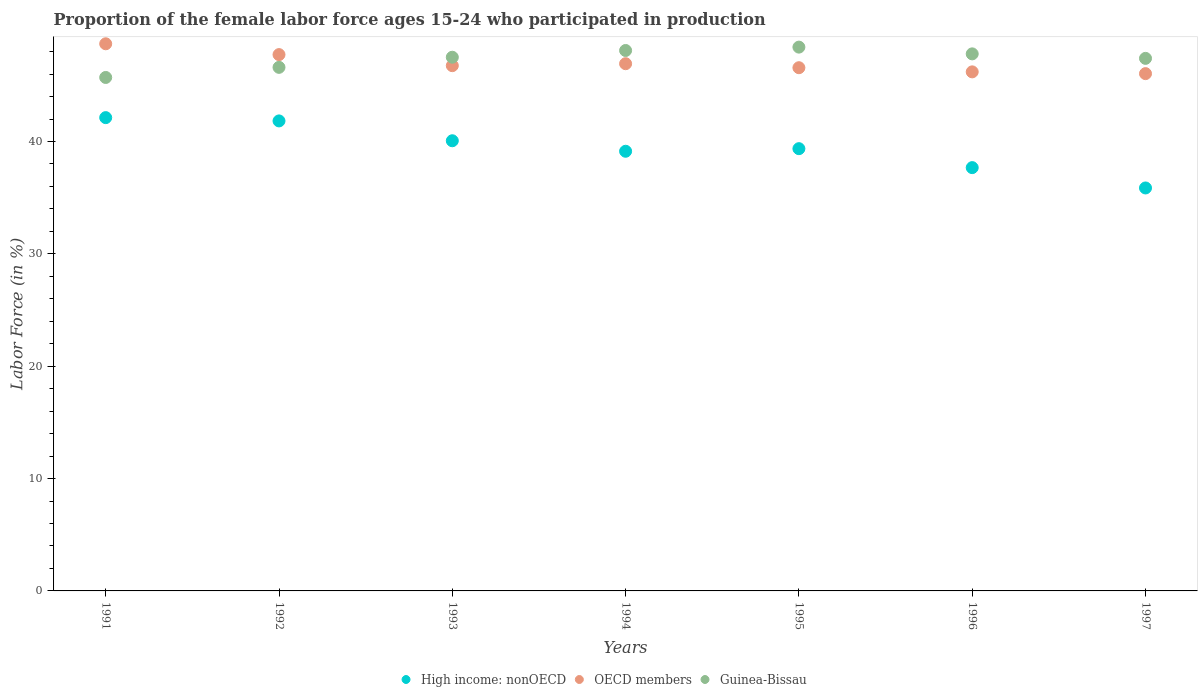How many different coloured dotlines are there?
Offer a terse response. 3. What is the proportion of the female labor force who participated in production in OECD members in 1997?
Your answer should be compact. 46.04. Across all years, what is the maximum proportion of the female labor force who participated in production in OECD members?
Your response must be concise. 48.7. Across all years, what is the minimum proportion of the female labor force who participated in production in OECD members?
Provide a short and direct response. 46.04. What is the total proportion of the female labor force who participated in production in Guinea-Bissau in the graph?
Your answer should be very brief. 331.5. What is the difference between the proportion of the female labor force who participated in production in High income: nonOECD in 1993 and that in 1994?
Your answer should be very brief. 0.93. What is the difference between the proportion of the female labor force who participated in production in OECD members in 1992 and the proportion of the female labor force who participated in production in Guinea-Bissau in 1995?
Keep it short and to the point. -0.67. What is the average proportion of the female labor force who participated in production in Guinea-Bissau per year?
Provide a short and direct response. 47.36. In the year 1997, what is the difference between the proportion of the female labor force who participated in production in OECD members and proportion of the female labor force who participated in production in Guinea-Bissau?
Make the answer very short. -1.36. In how many years, is the proportion of the female labor force who participated in production in Guinea-Bissau greater than 16 %?
Your answer should be compact. 7. What is the ratio of the proportion of the female labor force who participated in production in Guinea-Bissau in 1991 to that in 1995?
Make the answer very short. 0.94. Is the difference between the proportion of the female labor force who participated in production in OECD members in 1991 and 1994 greater than the difference between the proportion of the female labor force who participated in production in Guinea-Bissau in 1991 and 1994?
Keep it short and to the point. Yes. What is the difference between the highest and the second highest proportion of the female labor force who participated in production in OECD members?
Your response must be concise. 0.96. What is the difference between the highest and the lowest proportion of the female labor force who participated in production in OECD members?
Your response must be concise. 2.66. Is the sum of the proportion of the female labor force who participated in production in High income: nonOECD in 1991 and 1997 greater than the maximum proportion of the female labor force who participated in production in OECD members across all years?
Give a very brief answer. Yes. Is the proportion of the female labor force who participated in production in OECD members strictly less than the proportion of the female labor force who participated in production in Guinea-Bissau over the years?
Give a very brief answer. No. How many years are there in the graph?
Ensure brevity in your answer.  7. What is the difference between two consecutive major ticks on the Y-axis?
Your answer should be compact. 10. Are the values on the major ticks of Y-axis written in scientific E-notation?
Provide a succinct answer. No. Where does the legend appear in the graph?
Provide a succinct answer. Bottom center. How many legend labels are there?
Your response must be concise. 3. How are the legend labels stacked?
Make the answer very short. Horizontal. What is the title of the graph?
Make the answer very short. Proportion of the female labor force ages 15-24 who participated in production. Does "Libya" appear as one of the legend labels in the graph?
Make the answer very short. No. What is the label or title of the X-axis?
Provide a succinct answer. Years. What is the Labor Force (in %) in High income: nonOECD in 1991?
Provide a short and direct response. 42.12. What is the Labor Force (in %) in OECD members in 1991?
Make the answer very short. 48.7. What is the Labor Force (in %) of Guinea-Bissau in 1991?
Your answer should be very brief. 45.7. What is the Labor Force (in %) in High income: nonOECD in 1992?
Your answer should be compact. 41.83. What is the Labor Force (in %) in OECD members in 1992?
Provide a succinct answer. 47.73. What is the Labor Force (in %) of Guinea-Bissau in 1992?
Make the answer very short. 46.6. What is the Labor Force (in %) of High income: nonOECD in 1993?
Keep it short and to the point. 40.07. What is the Labor Force (in %) of OECD members in 1993?
Keep it short and to the point. 46.75. What is the Labor Force (in %) of Guinea-Bissau in 1993?
Your answer should be very brief. 47.5. What is the Labor Force (in %) in High income: nonOECD in 1994?
Offer a very short reply. 39.13. What is the Labor Force (in %) of OECD members in 1994?
Make the answer very short. 46.92. What is the Labor Force (in %) in Guinea-Bissau in 1994?
Give a very brief answer. 48.1. What is the Labor Force (in %) in High income: nonOECD in 1995?
Make the answer very short. 39.36. What is the Labor Force (in %) in OECD members in 1995?
Keep it short and to the point. 46.57. What is the Labor Force (in %) in Guinea-Bissau in 1995?
Offer a terse response. 48.4. What is the Labor Force (in %) of High income: nonOECD in 1996?
Offer a very short reply. 37.68. What is the Labor Force (in %) of OECD members in 1996?
Provide a short and direct response. 46.2. What is the Labor Force (in %) of Guinea-Bissau in 1996?
Your response must be concise. 47.8. What is the Labor Force (in %) of High income: nonOECD in 1997?
Your response must be concise. 35.87. What is the Labor Force (in %) of OECD members in 1997?
Give a very brief answer. 46.04. What is the Labor Force (in %) of Guinea-Bissau in 1997?
Give a very brief answer. 47.4. Across all years, what is the maximum Labor Force (in %) in High income: nonOECD?
Make the answer very short. 42.12. Across all years, what is the maximum Labor Force (in %) of OECD members?
Provide a short and direct response. 48.7. Across all years, what is the maximum Labor Force (in %) of Guinea-Bissau?
Your response must be concise. 48.4. Across all years, what is the minimum Labor Force (in %) of High income: nonOECD?
Provide a succinct answer. 35.87. Across all years, what is the minimum Labor Force (in %) in OECD members?
Your response must be concise. 46.04. Across all years, what is the minimum Labor Force (in %) of Guinea-Bissau?
Ensure brevity in your answer.  45.7. What is the total Labor Force (in %) in High income: nonOECD in the graph?
Make the answer very short. 276.06. What is the total Labor Force (in %) in OECD members in the graph?
Keep it short and to the point. 328.91. What is the total Labor Force (in %) of Guinea-Bissau in the graph?
Your response must be concise. 331.5. What is the difference between the Labor Force (in %) in High income: nonOECD in 1991 and that in 1992?
Make the answer very short. 0.29. What is the difference between the Labor Force (in %) of OECD members in 1991 and that in 1992?
Ensure brevity in your answer.  0.96. What is the difference between the Labor Force (in %) in Guinea-Bissau in 1991 and that in 1992?
Your answer should be compact. -0.9. What is the difference between the Labor Force (in %) of High income: nonOECD in 1991 and that in 1993?
Offer a very short reply. 2.06. What is the difference between the Labor Force (in %) in OECD members in 1991 and that in 1993?
Offer a terse response. 1.95. What is the difference between the Labor Force (in %) of Guinea-Bissau in 1991 and that in 1993?
Make the answer very short. -1.8. What is the difference between the Labor Force (in %) in High income: nonOECD in 1991 and that in 1994?
Keep it short and to the point. 2.99. What is the difference between the Labor Force (in %) in OECD members in 1991 and that in 1994?
Your answer should be very brief. 1.77. What is the difference between the Labor Force (in %) of Guinea-Bissau in 1991 and that in 1994?
Provide a short and direct response. -2.4. What is the difference between the Labor Force (in %) of High income: nonOECD in 1991 and that in 1995?
Offer a terse response. 2.76. What is the difference between the Labor Force (in %) of OECD members in 1991 and that in 1995?
Make the answer very short. 2.13. What is the difference between the Labor Force (in %) in Guinea-Bissau in 1991 and that in 1995?
Ensure brevity in your answer.  -2.7. What is the difference between the Labor Force (in %) in High income: nonOECD in 1991 and that in 1996?
Offer a very short reply. 4.45. What is the difference between the Labor Force (in %) of OECD members in 1991 and that in 1996?
Keep it short and to the point. 2.5. What is the difference between the Labor Force (in %) in Guinea-Bissau in 1991 and that in 1996?
Your response must be concise. -2.1. What is the difference between the Labor Force (in %) in High income: nonOECD in 1991 and that in 1997?
Provide a succinct answer. 6.26. What is the difference between the Labor Force (in %) in OECD members in 1991 and that in 1997?
Keep it short and to the point. 2.66. What is the difference between the Labor Force (in %) of Guinea-Bissau in 1991 and that in 1997?
Your answer should be compact. -1.7. What is the difference between the Labor Force (in %) in High income: nonOECD in 1992 and that in 1993?
Provide a succinct answer. 1.77. What is the difference between the Labor Force (in %) in OECD members in 1992 and that in 1993?
Offer a very short reply. 0.98. What is the difference between the Labor Force (in %) of Guinea-Bissau in 1992 and that in 1993?
Your answer should be very brief. -0.9. What is the difference between the Labor Force (in %) in High income: nonOECD in 1992 and that in 1994?
Offer a very short reply. 2.7. What is the difference between the Labor Force (in %) in OECD members in 1992 and that in 1994?
Make the answer very short. 0.81. What is the difference between the Labor Force (in %) of High income: nonOECD in 1992 and that in 1995?
Your answer should be very brief. 2.47. What is the difference between the Labor Force (in %) of OECD members in 1992 and that in 1995?
Provide a short and direct response. 1.17. What is the difference between the Labor Force (in %) of High income: nonOECD in 1992 and that in 1996?
Keep it short and to the point. 4.16. What is the difference between the Labor Force (in %) in OECD members in 1992 and that in 1996?
Your answer should be compact. 1.54. What is the difference between the Labor Force (in %) in High income: nonOECD in 1992 and that in 1997?
Offer a terse response. 5.97. What is the difference between the Labor Force (in %) in OECD members in 1992 and that in 1997?
Your answer should be compact. 1.69. What is the difference between the Labor Force (in %) in High income: nonOECD in 1993 and that in 1994?
Provide a succinct answer. 0.93. What is the difference between the Labor Force (in %) in OECD members in 1993 and that in 1994?
Your answer should be very brief. -0.17. What is the difference between the Labor Force (in %) in Guinea-Bissau in 1993 and that in 1994?
Offer a very short reply. -0.6. What is the difference between the Labor Force (in %) of High income: nonOECD in 1993 and that in 1995?
Offer a terse response. 0.7. What is the difference between the Labor Force (in %) in OECD members in 1993 and that in 1995?
Your answer should be very brief. 0.18. What is the difference between the Labor Force (in %) in Guinea-Bissau in 1993 and that in 1995?
Your answer should be very brief. -0.9. What is the difference between the Labor Force (in %) of High income: nonOECD in 1993 and that in 1996?
Provide a short and direct response. 2.39. What is the difference between the Labor Force (in %) of OECD members in 1993 and that in 1996?
Provide a succinct answer. 0.55. What is the difference between the Labor Force (in %) of High income: nonOECD in 1993 and that in 1997?
Offer a terse response. 4.2. What is the difference between the Labor Force (in %) in OECD members in 1993 and that in 1997?
Your answer should be very brief. 0.71. What is the difference between the Labor Force (in %) in High income: nonOECD in 1994 and that in 1995?
Your answer should be compact. -0.23. What is the difference between the Labor Force (in %) of OECD members in 1994 and that in 1995?
Provide a short and direct response. 0.36. What is the difference between the Labor Force (in %) of Guinea-Bissau in 1994 and that in 1995?
Offer a terse response. -0.3. What is the difference between the Labor Force (in %) in High income: nonOECD in 1994 and that in 1996?
Provide a short and direct response. 1.46. What is the difference between the Labor Force (in %) of OECD members in 1994 and that in 1996?
Offer a very short reply. 0.73. What is the difference between the Labor Force (in %) in High income: nonOECD in 1994 and that in 1997?
Ensure brevity in your answer.  3.27. What is the difference between the Labor Force (in %) in OECD members in 1994 and that in 1997?
Keep it short and to the point. 0.88. What is the difference between the Labor Force (in %) of High income: nonOECD in 1995 and that in 1996?
Offer a very short reply. 1.69. What is the difference between the Labor Force (in %) in OECD members in 1995 and that in 1996?
Ensure brevity in your answer.  0.37. What is the difference between the Labor Force (in %) of Guinea-Bissau in 1995 and that in 1996?
Keep it short and to the point. 0.6. What is the difference between the Labor Force (in %) in High income: nonOECD in 1995 and that in 1997?
Offer a very short reply. 3.5. What is the difference between the Labor Force (in %) in OECD members in 1995 and that in 1997?
Your answer should be compact. 0.53. What is the difference between the Labor Force (in %) in Guinea-Bissau in 1995 and that in 1997?
Keep it short and to the point. 1. What is the difference between the Labor Force (in %) in High income: nonOECD in 1996 and that in 1997?
Ensure brevity in your answer.  1.81. What is the difference between the Labor Force (in %) in OECD members in 1996 and that in 1997?
Provide a succinct answer. 0.16. What is the difference between the Labor Force (in %) of Guinea-Bissau in 1996 and that in 1997?
Ensure brevity in your answer.  0.4. What is the difference between the Labor Force (in %) of High income: nonOECD in 1991 and the Labor Force (in %) of OECD members in 1992?
Your answer should be very brief. -5.61. What is the difference between the Labor Force (in %) of High income: nonOECD in 1991 and the Labor Force (in %) of Guinea-Bissau in 1992?
Your answer should be compact. -4.48. What is the difference between the Labor Force (in %) in OECD members in 1991 and the Labor Force (in %) in Guinea-Bissau in 1992?
Ensure brevity in your answer.  2.1. What is the difference between the Labor Force (in %) of High income: nonOECD in 1991 and the Labor Force (in %) of OECD members in 1993?
Offer a terse response. -4.63. What is the difference between the Labor Force (in %) of High income: nonOECD in 1991 and the Labor Force (in %) of Guinea-Bissau in 1993?
Your answer should be very brief. -5.38. What is the difference between the Labor Force (in %) of OECD members in 1991 and the Labor Force (in %) of Guinea-Bissau in 1993?
Give a very brief answer. 1.2. What is the difference between the Labor Force (in %) in High income: nonOECD in 1991 and the Labor Force (in %) in OECD members in 1994?
Provide a short and direct response. -4.8. What is the difference between the Labor Force (in %) of High income: nonOECD in 1991 and the Labor Force (in %) of Guinea-Bissau in 1994?
Your answer should be very brief. -5.98. What is the difference between the Labor Force (in %) in OECD members in 1991 and the Labor Force (in %) in Guinea-Bissau in 1994?
Your answer should be very brief. 0.6. What is the difference between the Labor Force (in %) of High income: nonOECD in 1991 and the Labor Force (in %) of OECD members in 1995?
Ensure brevity in your answer.  -4.44. What is the difference between the Labor Force (in %) in High income: nonOECD in 1991 and the Labor Force (in %) in Guinea-Bissau in 1995?
Offer a very short reply. -6.28. What is the difference between the Labor Force (in %) in OECD members in 1991 and the Labor Force (in %) in Guinea-Bissau in 1995?
Offer a terse response. 0.3. What is the difference between the Labor Force (in %) of High income: nonOECD in 1991 and the Labor Force (in %) of OECD members in 1996?
Give a very brief answer. -4.07. What is the difference between the Labor Force (in %) of High income: nonOECD in 1991 and the Labor Force (in %) of Guinea-Bissau in 1996?
Give a very brief answer. -5.68. What is the difference between the Labor Force (in %) of OECD members in 1991 and the Labor Force (in %) of Guinea-Bissau in 1996?
Keep it short and to the point. 0.9. What is the difference between the Labor Force (in %) of High income: nonOECD in 1991 and the Labor Force (in %) of OECD members in 1997?
Provide a short and direct response. -3.92. What is the difference between the Labor Force (in %) in High income: nonOECD in 1991 and the Labor Force (in %) in Guinea-Bissau in 1997?
Provide a short and direct response. -5.28. What is the difference between the Labor Force (in %) in OECD members in 1991 and the Labor Force (in %) in Guinea-Bissau in 1997?
Provide a succinct answer. 1.3. What is the difference between the Labor Force (in %) in High income: nonOECD in 1992 and the Labor Force (in %) in OECD members in 1993?
Ensure brevity in your answer.  -4.92. What is the difference between the Labor Force (in %) of High income: nonOECD in 1992 and the Labor Force (in %) of Guinea-Bissau in 1993?
Your response must be concise. -5.67. What is the difference between the Labor Force (in %) of OECD members in 1992 and the Labor Force (in %) of Guinea-Bissau in 1993?
Give a very brief answer. 0.23. What is the difference between the Labor Force (in %) of High income: nonOECD in 1992 and the Labor Force (in %) of OECD members in 1994?
Offer a very short reply. -5.09. What is the difference between the Labor Force (in %) of High income: nonOECD in 1992 and the Labor Force (in %) of Guinea-Bissau in 1994?
Offer a very short reply. -6.27. What is the difference between the Labor Force (in %) of OECD members in 1992 and the Labor Force (in %) of Guinea-Bissau in 1994?
Provide a succinct answer. -0.37. What is the difference between the Labor Force (in %) of High income: nonOECD in 1992 and the Labor Force (in %) of OECD members in 1995?
Make the answer very short. -4.74. What is the difference between the Labor Force (in %) in High income: nonOECD in 1992 and the Labor Force (in %) in Guinea-Bissau in 1995?
Provide a succinct answer. -6.57. What is the difference between the Labor Force (in %) in OECD members in 1992 and the Labor Force (in %) in Guinea-Bissau in 1995?
Offer a terse response. -0.67. What is the difference between the Labor Force (in %) of High income: nonOECD in 1992 and the Labor Force (in %) of OECD members in 1996?
Keep it short and to the point. -4.37. What is the difference between the Labor Force (in %) of High income: nonOECD in 1992 and the Labor Force (in %) of Guinea-Bissau in 1996?
Your answer should be very brief. -5.97. What is the difference between the Labor Force (in %) in OECD members in 1992 and the Labor Force (in %) in Guinea-Bissau in 1996?
Your answer should be compact. -0.07. What is the difference between the Labor Force (in %) of High income: nonOECD in 1992 and the Labor Force (in %) of OECD members in 1997?
Ensure brevity in your answer.  -4.21. What is the difference between the Labor Force (in %) of High income: nonOECD in 1992 and the Labor Force (in %) of Guinea-Bissau in 1997?
Ensure brevity in your answer.  -5.57. What is the difference between the Labor Force (in %) of OECD members in 1992 and the Labor Force (in %) of Guinea-Bissau in 1997?
Make the answer very short. 0.33. What is the difference between the Labor Force (in %) of High income: nonOECD in 1993 and the Labor Force (in %) of OECD members in 1994?
Keep it short and to the point. -6.86. What is the difference between the Labor Force (in %) of High income: nonOECD in 1993 and the Labor Force (in %) of Guinea-Bissau in 1994?
Provide a succinct answer. -8.03. What is the difference between the Labor Force (in %) in OECD members in 1993 and the Labor Force (in %) in Guinea-Bissau in 1994?
Give a very brief answer. -1.35. What is the difference between the Labor Force (in %) in High income: nonOECD in 1993 and the Labor Force (in %) in OECD members in 1995?
Provide a short and direct response. -6.5. What is the difference between the Labor Force (in %) of High income: nonOECD in 1993 and the Labor Force (in %) of Guinea-Bissau in 1995?
Your answer should be compact. -8.33. What is the difference between the Labor Force (in %) of OECD members in 1993 and the Labor Force (in %) of Guinea-Bissau in 1995?
Provide a succinct answer. -1.65. What is the difference between the Labor Force (in %) in High income: nonOECD in 1993 and the Labor Force (in %) in OECD members in 1996?
Keep it short and to the point. -6.13. What is the difference between the Labor Force (in %) in High income: nonOECD in 1993 and the Labor Force (in %) in Guinea-Bissau in 1996?
Provide a short and direct response. -7.73. What is the difference between the Labor Force (in %) of OECD members in 1993 and the Labor Force (in %) of Guinea-Bissau in 1996?
Keep it short and to the point. -1.05. What is the difference between the Labor Force (in %) in High income: nonOECD in 1993 and the Labor Force (in %) in OECD members in 1997?
Provide a short and direct response. -5.97. What is the difference between the Labor Force (in %) of High income: nonOECD in 1993 and the Labor Force (in %) of Guinea-Bissau in 1997?
Your answer should be very brief. -7.33. What is the difference between the Labor Force (in %) in OECD members in 1993 and the Labor Force (in %) in Guinea-Bissau in 1997?
Provide a succinct answer. -0.65. What is the difference between the Labor Force (in %) of High income: nonOECD in 1994 and the Labor Force (in %) of OECD members in 1995?
Offer a very short reply. -7.44. What is the difference between the Labor Force (in %) of High income: nonOECD in 1994 and the Labor Force (in %) of Guinea-Bissau in 1995?
Provide a succinct answer. -9.27. What is the difference between the Labor Force (in %) of OECD members in 1994 and the Labor Force (in %) of Guinea-Bissau in 1995?
Provide a succinct answer. -1.48. What is the difference between the Labor Force (in %) of High income: nonOECD in 1994 and the Labor Force (in %) of OECD members in 1996?
Provide a succinct answer. -7.07. What is the difference between the Labor Force (in %) of High income: nonOECD in 1994 and the Labor Force (in %) of Guinea-Bissau in 1996?
Offer a terse response. -8.67. What is the difference between the Labor Force (in %) of OECD members in 1994 and the Labor Force (in %) of Guinea-Bissau in 1996?
Your response must be concise. -0.88. What is the difference between the Labor Force (in %) in High income: nonOECD in 1994 and the Labor Force (in %) in OECD members in 1997?
Ensure brevity in your answer.  -6.91. What is the difference between the Labor Force (in %) in High income: nonOECD in 1994 and the Labor Force (in %) in Guinea-Bissau in 1997?
Your response must be concise. -8.27. What is the difference between the Labor Force (in %) in OECD members in 1994 and the Labor Force (in %) in Guinea-Bissau in 1997?
Your answer should be compact. -0.48. What is the difference between the Labor Force (in %) of High income: nonOECD in 1995 and the Labor Force (in %) of OECD members in 1996?
Provide a short and direct response. -6.84. What is the difference between the Labor Force (in %) of High income: nonOECD in 1995 and the Labor Force (in %) of Guinea-Bissau in 1996?
Give a very brief answer. -8.44. What is the difference between the Labor Force (in %) of OECD members in 1995 and the Labor Force (in %) of Guinea-Bissau in 1996?
Make the answer very short. -1.23. What is the difference between the Labor Force (in %) of High income: nonOECD in 1995 and the Labor Force (in %) of OECD members in 1997?
Keep it short and to the point. -6.68. What is the difference between the Labor Force (in %) of High income: nonOECD in 1995 and the Labor Force (in %) of Guinea-Bissau in 1997?
Ensure brevity in your answer.  -8.04. What is the difference between the Labor Force (in %) in OECD members in 1995 and the Labor Force (in %) in Guinea-Bissau in 1997?
Ensure brevity in your answer.  -0.83. What is the difference between the Labor Force (in %) in High income: nonOECD in 1996 and the Labor Force (in %) in OECD members in 1997?
Provide a short and direct response. -8.37. What is the difference between the Labor Force (in %) in High income: nonOECD in 1996 and the Labor Force (in %) in Guinea-Bissau in 1997?
Keep it short and to the point. -9.72. What is the difference between the Labor Force (in %) in OECD members in 1996 and the Labor Force (in %) in Guinea-Bissau in 1997?
Your answer should be very brief. -1.2. What is the average Labor Force (in %) in High income: nonOECD per year?
Keep it short and to the point. 39.44. What is the average Labor Force (in %) in OECD members per year?
Keep it short and to the point. 46.99. What is the average Labor Force (in %) of Guinea-Bissau per year?
Provide a short and direct response. 47.36. In the year 1991, what is the difference between the Labor Force (in %) of High income: nonOECD and Labor Force (in %) of OECD members?
Make the answer very short. -6.57. In the year 1991, what is the difference between the Labor Force (in %) of High income: nonOECD and Labor Force (in %) of Guinea-Bissau?
Keep it short and to the point. -3.58. In the year 1991, what is the difference between the Labor Force (in %) in OECD members and Labor Force (in %) in Guinea-Bissau?
Offer a very short reply. 3. In the year 1992, what is the difference between the Labor Force (in %) of High income: nonOECD and Labor Force (in %) of OECD members?
Offer a terse response. -5.9. In the year 1992, what is the difference between the Labor Force (in %) in High income: nonOECD and Labor Force (in %) in Guinea-Bissau?
Make the answer very short. -4.77. In the year 1992, what is the difference between the Labor Force (in %) of OECD members and Labor Force (in %) of Guinea-Bissau?
Make the answer very short. 1.13. In the year 1993, what is the difference between the Labor Force (in %) of High income: nonOECD and Labor Force (in %) of OECD members?
Make the answer very short. -6.68. In the year 1993, what is the difference between the Labor Force (in %) in High income: nonOECD and Labor Force (in %) in Guinea-Bissau?
Keep it short and to the point. -7.43. In the year 1993, what is the difference between the Labor Force (in %) in OECD members and Labor Force (in %) in Guinea-Bissau?
Your answer should be very brief. -0.75. In the year 1994, what is the difference between the Labor Force (in %) in High income: nonOECD and Labor Force (in %) in OECD members?
Make the answer very short. -7.79. In the year 1994, what is the difference between the Labor Force (in %) in High income: nonOECD and Labor Force (in %) in Guinea-Bissau?
Make the answer very short. -8.97. In the year 1994, what is the difference between the Labor Force (in %) of OECD members and Labor Force (in %) of Guinea-Bissau?
Offer a terse response. -1.18. In the year 1995, what is the difference between the Labor Force (in %) in High income: nonOECD and Labor Force (in %) in OECD members?
Make the answer very short. -7.21. In the year 1995, what is the difference between the Labor Force (in %) of High income: nonOECD and Labor Force (in %) of Guinea-Bissau?
Make the answer very short. -9.04. In the year 1995, what is the difference between the Labor Force (in %) of OECD members and Labor Force (in %) of Guinea-Bissau?
Offer a very short reply. -1.83. In the year 1996, what is the difference between the Labor Force (in %) in High income: nonOECD and Labor Force (in %) in OECD members?
Offer a terse response. -8.52. In the year 1996, what is the difference between the Labor Force (in %) of High income: nonOECD and Labor Force (in %) of Guinea-Bissau?
Give a very brief answer. -10.12. In the year 1996, what is the difference between the Labor Force (in %) of OECD members and Labor Force (in %) of Guinea-Bissau?
Your answer should be very brief. -1.6. In the year 1997, what is the difference between the Labor Force (in %) in High income: nonOECD and Labor Force (in %) in OECD members?
Provide a succinct answer. -10.18. In the year 1997, what is the difference between the Labor Force (in %) of High income: nonOECD and Labor Force (in %) of Guinea-Bissau?
Your answer should be compact. -11.53. In the year 1997, what is the difference between the Labor Force (in %) of OECD members and Labor Force (in %) of Guinea-Bissau?
Give a very brief answer. -1.36. What is the ratio of the Labor Force (in %) of High income: nonOECD in 1991 to that in 1992?
Offer a very short reply. 1.01. What is the ratio of the Labor Force (in %) of OECD members in 1991 to that in 1992?
Your answer should be compact. 1.02. What is the ratio of the Labor Force (in %) of Guinea-Bissau in 1991 to that in 1992?
Offer a very short reply. 0.98. What is the ratio of the Labor Force (in %) in High income: nonOECD in 1991 to that in 1993?
Your answer should be very brief. 1.05. What is the ratio of the Labor Force (in %) in OECD members in 1991 to that in 1993?
Your answer should be very brief. 1.04. What is the ratio of the Labor Force (in %) of Guinea-Bissau in 1991 to that in 1993?
Your answer should be very brief. 0.96. What is the ratio of the Labor Force (in %) in High income: nonOECD in 1991 to that in 1994?
Your answer should be very brief. 1.08. What is the ratio of the Labor Force (in %) of OECD members in 1991 to that in 1994?
Make the answer very short. 1.04. What is the ratio of the Labor Force (in %) of Guinea-Bissau in 1991 to that in 1994?
Your response must be concise. 0.95. What is the ratio of the Labor Force (in %) in High income: nonOECD in 1991 to that in 1995?
Provide a succinct answer. 1.07. What is the ratio of the Labor Force (in %) of OECD members in 1991 to that in 1995?
Your answer should be compact. 1.05. What is the ratio of the Labor Force (in %) in Guinea-Bissau in 1991 to that in 1995?
Offer a terse response. 0.94. What is the ratio of the Labor Force (in %) in High income: nonOECD in 1991 to that in 1996?
Your response must be concise. 1.12. What is the ratio of the Labor Force (in %) of OECD members in 1991 to that in 1996?
Your answer should be very brief. 1.05. What is the ratio of the Labor Force (in %) in Guinea-Bissau in 1991 to that in 1996?
Make the answer very short. 0.96. What is the ratio of the Labor Force (in %) in High income: nonOECD in 1991 to that in 1997?
Your answer should be compact. 1.17. What is the ratio of the Labor Force (in %) of OECD members in 1991 to that in 1997?
Make the answer very short. 1.06. What is the ratio of the Labor Force (in %) in Guinea-Bissau in 1991 to that in 1997?
Provide a short and direct response. 0.96. What is the ratio of the Labor Force (in %) of High income: nonOECD in 1992 to that in 1993?
Ensure brevity in your answer.  1.04. What is the ratio of the Labor Force (in %) of Guinea-Bissau in 1992 to that in 1993?
Ensure brevity in your answer.  0.98. What is the ratio of the Labor Force (in %) in High income: nonOECD in 1992 to that in 1994?
Keep it short and to the point. 1.07. What is the ratio of the Labor Force (in %) of OECD members in 1992 to that in 1994?
Give a very brief answer. 1.02. What is the ratio of the Labor Force (in %) of Guinea-Bissau in 1992 to that in 1994?
Offer a very short reply. 0.97. What is the ratio of the Labor Force (in %) in High income: nonOECD in 1992 to that in 1995?
Make the answer very short. 1.06. What is the ratio of the Labor Force (in %) in OECD members in 1992 to that in 1995?
Make the answer very short. 1.02. What is the ratio of the Labor Force (in %) of Guinea-Bissau in 1992 to that in 1995?
Provide a short and direct response. 0.96. What is the ratio of the Labor Force (in %) in High income: nonOECD in 1992 to that in 1996?
Offer a terse response. 1.11. What is the ratio of the Labor Force (in %) in OECD members in 1992 to that in 1996?
Make the answer very short. 1.03. What is the ratio of the Labor Force (in %) in Guinea-Bissau in 1992 to that in 1996?
Your response must be concise. 0.97. What is the ratio of the Labor Force (in %) in High income: nonOECD in 1992 to that in 1997?
Keep it short and to the point. 1.17. What is the ratio of the Labor Force (in %) of OECD members in 1992 to that in 1997?
Keep it short and to the point. 1.04. What is the ratio of the Labor Force (in %) of Guinea-Bissau in 1992 to that in 1997?
Your answer should be very brief. 0.98. What is the ratio of the Labor Force (in %) in High income: nonOECD in 1993 to that in 1994?
Your answer should be compact. 1.02. What is the ratio of the Labor Force (in %) of OECD members in 1993 to that in 1994?
Offer a very short reply. 1. What is the ratio of the Labor Force (in %) in Guinea-Bissau in 1993 to that in 1994?
Give a very brief answer. 0.99. What is the ratio of the Labor Force (in %) in High income: nonOECD in 1993 to that in 1995?
Provide a short and direct response. 1.02. What is the ratio of the Labor Force (in %) in OECD members in 1993 to that in 1995?
Make the answer very short. 1. What is the ratio of the Labor Force (in %) of Guinea-Bissau in 1993 to that in 1995?
Offer a very short reply. 0.98. What is the ratio of the Labor Force (in %) of High income: nonOECD in 1993 to that in 1996?
Keep it short and to the point. 1.06. What is the ratio of the Labor Force (in %) of OECD members in 1993 to that in 1996?
Offer a very short reply. 1.01. What is the ratio of the Labor Force (in %) in Guinea-Bissau in 1993 to that in 1996?
Keep it short and to the point. 0.99. What is the ratio of the Labor Force (in %) of High income: nonOECD in 1993 to that in 1997?
Give a very brief answer. 1.12. What is the ratio of the Labor Force (in %) in OECD members in 1993 to that in 1997?
Make the answer very short. 1.02. What is the ratio of the Labor Force (in %) in OECD members in 1994 to that in 1995?
Provide a short and direct response. 1.01. What is the ratio of the Labor Force (in %) of High income: nonOECD in 1994 to that in 1996?
Ensure brevity in your answer.  1.04. What is the ratio of the Labor Force (in %) in OECD members in 1994 to that in 1996?
Offer a very short reply. 1.02. What is the ratio of the Labor Force (in %) of Guinea-Bissau in 1994 to that in 1996?
Offer a terse response. 1.01. What is the ratio of the Labor Force (in %) of High income: nonOECD in 1994 to that in 1997?
Your response must be concise. 1.09. What is the ratio of the Labor Force (in %) in OECD members in 1994 to that in 1997?
Offer a terse response. 1.02. What is the ratio of the Labor Force (in %) in Guinea-Bissau in 1994 to that in 1997?
Offer a terse response. 1.01. What is the ratio of the Labor Force (in %) of High income: nonOECD in 1995 to that in 1996?
Your answer should be very brief. 1.04. What is the ratio of the Labor Force (in %) in OECD members in 1995 to that in 1996?
Provide a short and direct response. 1.01. What is the ratio of the Labor Force (in %) of Guinea-Bissau in 1995 to that in 1996?
Provide a succinct answer. 1.01. What is the ratio of the Labor Force (in %) of High income: nonOECD in 1995 to that in 1997?
Offer a very short reply. 1.1. What is the ratio of the Labor Force (in %) in OECD members in 1995 to that in 1997?
Provide a short and direct response. 1.01. What is the ratio of the Labor Force (in %) in Guinea-Bissau in 1995 to that in 1997?
Offer a very short reply. 1.02. What is the ratio of the Labor Force (in %) in High income: nonOECD in 1996 to that in 1997?
Your response must be concise. 1.05. What is the ratio of the Labor Force (in %) in OECD members in 1996 to that in 1997?
Keep it short and to the point. 1. What is the ratio of the Labor Force (in %) of Guinea-Bissau in 1996 to that in 1997?
Offer a very short reply. 1.01. What is the difference between the highest and the second highest Labor Force (in %) of High income: nonOECD?
Keep it short and to the point. 0.29. What is the difference between the highest and the second highest Labor Force (in %) in OECD members?
Your answer should be very brief. 0.96. What is the difference between the highest and the second highest Labor Force (in %) of Guinea-Bissau?
Provide a short and direct response. 0.3. What is the difference between the highest and the lowest Labor Force (in %) of High income: nonOECD?
Make the answer very short. 6.26. What is the difference between the highest and the lowest Labor Force (in %) in OECD members?
Your response must be concise. 2.66. What is the difference between the highest and the lowest Labor Force (in %) in Guinea-Bissau?
Provide a short and direct response. 2.7. 